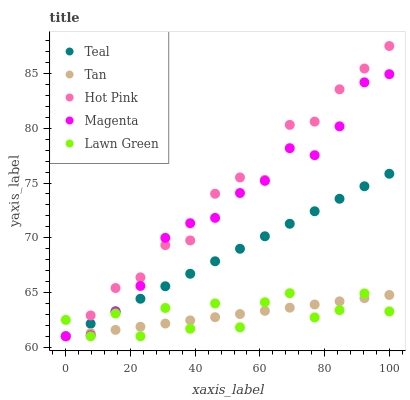Does Tan have the minimum area under the curve?
Answer yes or no. Yes. Does Hot Pink have the maximum area under the curve?
Answer yes or no. Yes. Does Hot Pink have the minimum area under the curve?
Answer yes or no. No. Does Tan have the maximum area under the curve?
Answer yes or no. No. Is Tan the smoothest?
Answer yes or no. Yes. Is Lawn Green the roughest?
Answer yes or no. Yes. Is Hot Pink the smoothest?
Answer yes or no. No. Is Hot Pink the roughest?
Answer yes or no. No. Does Lawn Green have the lowest value?
Answer yes or no. Yes. Does Hot Pink have the highest value?
Answer yes or no. Yes. Does Tan have the highest value?
Answer yes or no. No. Does Teal intersect Hot Pink?
Answer yes or no. Yes. Is Teal less than Hot Pink?
Answer yes or no. No. Is Teal greater than Hot Pink?
Answer yes or no. No. 